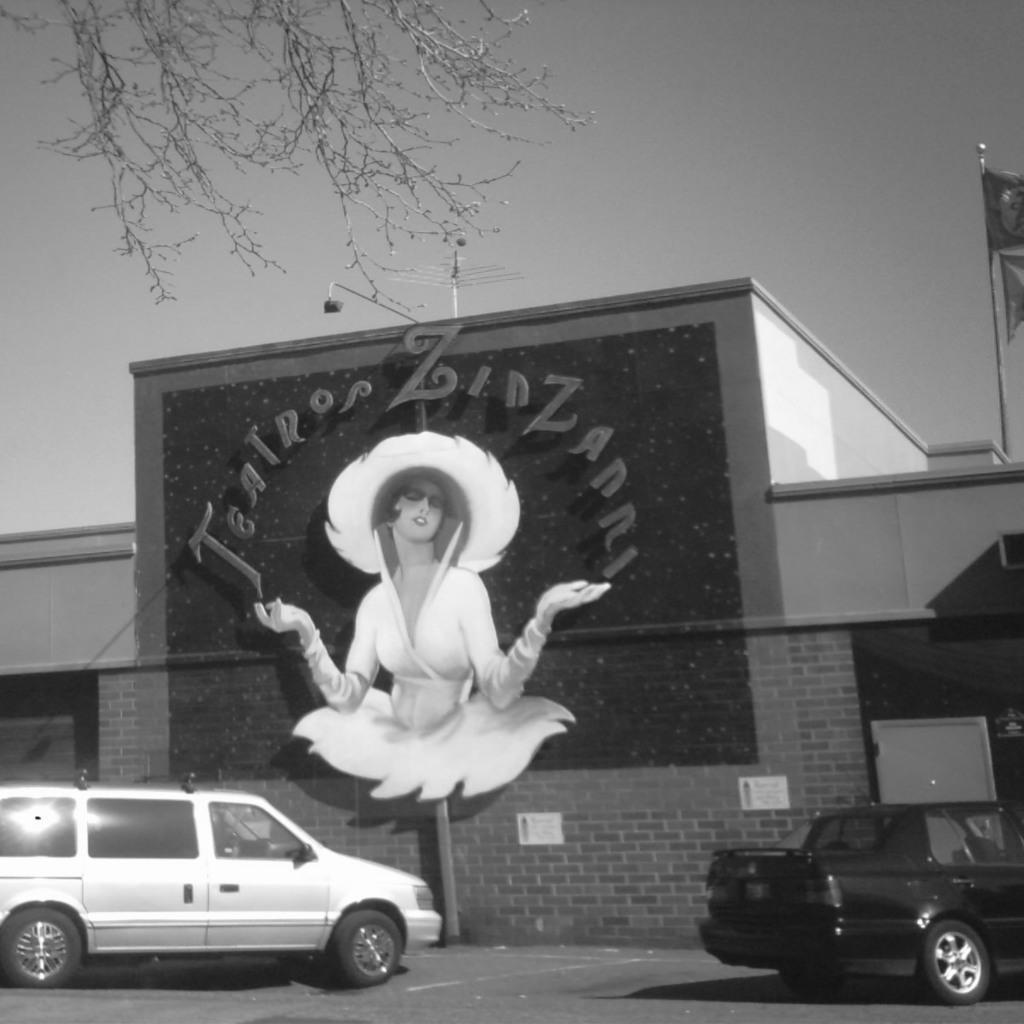Describe this image in one or two sentences. In the center of the image we can see two vehicles on the road. In the background, we can see the sky, branches with leaves, one building with some text and a person's image and some objects. 